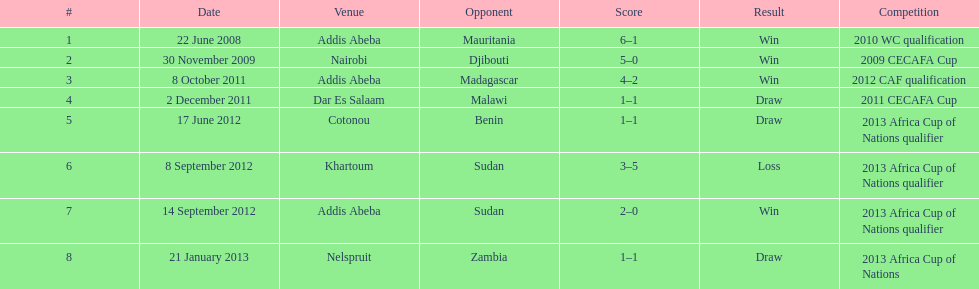For each winning game, what was their score? 6-1, 5-0, 4-2, 2-0. 